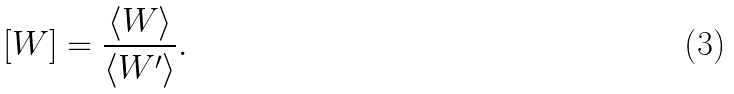<formula> <loc_0><loc_0><loc_500><loc_500>[ W ] = \frac { \langle W \rangle } { \langle W ^ { \prime } \rangle } .</formula> 